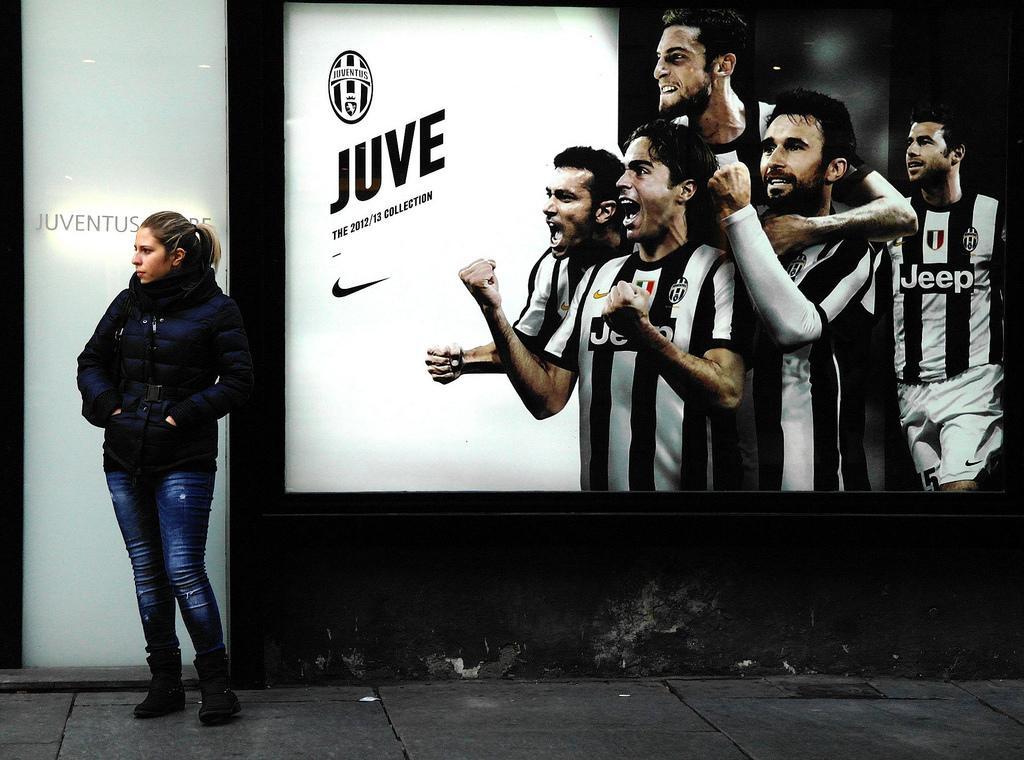Please provide a concise description of this image. This is an edited image. On the left side, we see the woman in the black jacket is standing. Behind her, we see a wall in white and black color. On the right side, we see five men are standing. Behind them, we see a white color board with some text written on it. At the bottom of the picture, we see the pavement. 